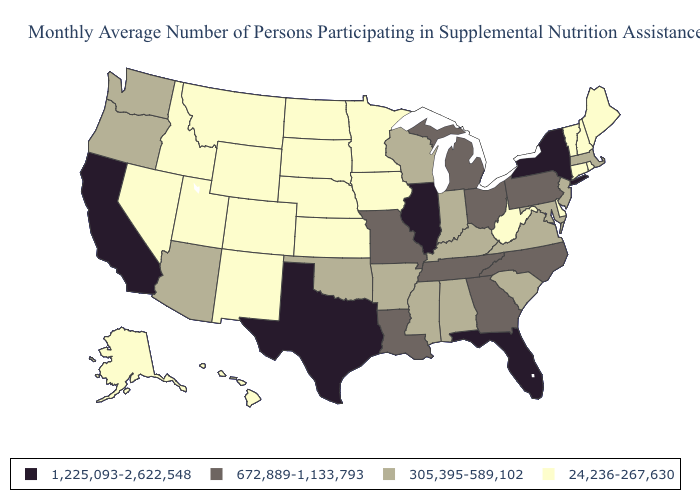What is the highest value in the USA?
Quick response, please. 1,225,093-2,622,548. What is the value of Montana?
Quick response, please. 24,236-267,630. Among the states that border Nebraska , which have the highest value?
Short answer required. Missouri. Which states have the lowest value in the USA?
Be succinct. Alaska, Colorado, Connecticut, Delaware, Hawaii, Idaho, Iowa, Kansas, Maine, Minnesota, Montana, Nebraska, Nevada, New Hampshire, New Mexico, North Dakota, Rhode Island, South Dakota, Utah, Vermont, West Virginia, Wyoming. Name the states that have a value in the range 672,889-1,133,793?
Give a very brief answer. Georgia, Louisiana, Michigan, Missouri, North Carolina, Ohio, Pennsylvania, Tennessee. What is the value of Missouri?
Answer briefly. 672,889-1,133,793. Does the map have missing data?
Answer briefly. No. Among the states that border Nebraska , does Missouri have the highest value?
Write a very short answer. Yes. Does Maryland have the lowest value in the USA?
Answer briefly. No. Name the states that have a value in the range 305,395-589,102?
Be succinct. Alabama, Arizona, Arkansas, Indiana, Kentucky, Maryland, Massachusetts, Mississippi, New Jersey, Oklahoma, Oregon, South Carolina, Virginia, Washington, Wisconsin. Name the states that have a value in the range 1,225,093-2,622,548?
Keep it brief. California, Florida, Illinois, New York, Texas. Which states have the lowest value in the MidWest?
Quick response, please. Iowa, Kansas, Minnesota, Nebraska, North Dakota, South Dakota. Which states hav the highest value in the MidWest?
Answer briefly. Illinois. What is the lowest value in states that border Indiana?
Give a very brief answer. 305,395-589,102. Which states have the lowest value in the South?
Concise answer only. Delaware, West Virginia. 